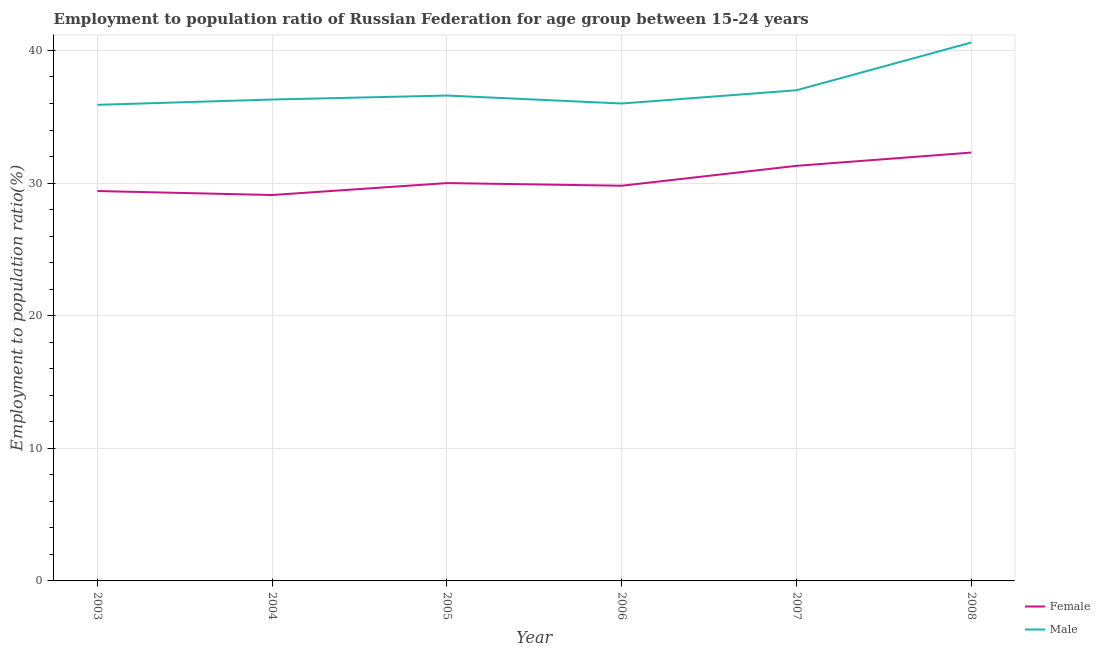Is the number of lines equal to the number of legend labels?
Keep it short and to the point. Yes. What is the employment to population ratio(female) in 2004?
Your response must be concise. 29.1. Across all years, what is the maximum employment to population ratio(male)?
Offer a terse response. 40.6. Across all years, what is the minimum employment to population ratio(female)?
Provide a succinct answer. 29.1. What is the total employment to population ratio(male) in the graph?
Ensure brevity in your answer.  222.4. What is the difference between the employment to population ratio(female) in 2005 and that in 2007?
Provide a short and direct response. -1.3. What is the difference between the employment to population ratio(male) in 2004 and the employment to population ratio(female) in 2007?
Provide a short and direct response. 5. What is the average employment to population ratio(female) per year?
Ensure brevity in your answer.  30.32. In the year 2007, what is the difference between the employment to population ratio(male) and employment to population ratio(female)?
Make the answer very short. 5.7. In how many years, is the employment to population ratio(female) greater than 2 %?
Your response must be concise. 6. What is the ratio of the employment to population ratio(male) in 2004 to that in 2007?
Provide a succinct answer. 0.98. Is the employment to population ratio(male) in 2004 less than that in 2007?
Provide a short and direct response. Yes. What is the difference between the highest and the second highest employment to population ratio(female)?
Provide a succinct answer. 1. What is the difference between the highest and the lowest employment to population ratio(female)?
Provide a succinct answer. 3.2. In how many years, is the employment to population ratio(female) greater than the average employment to population ratio(female) taken over all years?
Ensure brevity in your answer.  2. Does the employment to population ratio(male) monotonically increase over the years?
Provide a short and direct response. No. Is the employment to population ratio(male) strictly greater than the employment to population ratio(female) over the years?
Keep it short and to the point. Yes. Is the employment to population ratio(male) strictly less than the employment to population ratio(female) over the years?
Offer a very short reply. No. How many lines are there?
Provide a succinct answer. 2. How many years are there in the graph?
Offer a terse response. 6. What is the difference between two consecutive major ticks on the Y-axis?
Keep it short and to the point. 10. Are the values on the major ticks of Y-axis written in scientific E-notation?
Your answer should be very brief. No. How many legend labels are there?
Give a very brief answer. 2. What is the title of the graph?
Your answer should be compact. Employment to population ratio of Russian Federation for age group between 15-24 years. What is the label or title of the Y-axis?
Provide a succinct answer. Employment to population ratio(%). What is the Employment to population ratio(%) of Female in 2003?
Offer a terse response. 29.4. What is the Employment to population ratio(%) of Male in 2003?
Your response must be concise. 35.9. What is the Employment to population ratio(%) of Female in 2004?
Provide a succinct answer. 29.1. What is the Employment to population ratio(%) in Male in 2004?
Offer a very short reply. 36.3. What is the Employment to population ratio(%) of Female in 2005?
Ensure brevity in your answer.  30. What is the Employment to population ratio(%) in Male in 2005?
Your response must be concise. 36.6. What is the Employment to population ratio(%) of Female in 2006?
Keep it short and to the point. 29.8. What is the Employment to population ratio(%) in Male in 2006?
Make the answer very short. 36. What is the Employment to population ratio(%) of Female in 2007?
Make the answer very short. 31.3. What is the Employment to population ratio(%) of Male in 2007?
Ensure brevity in your answer.  37. What is the Employment to population ratio(%) of Female in 2008?
Provide a short and direct response. 32.3. What is the Employment to population ratio(%) of Male in 2008?
Your answer should be very brief. 40.6. Across all years, what is the maximum Employment to population ratio(%) in Female?
Provide a short and direct response. 32.3. Across all years, what is the maximum Employment to population ratio(%) of Male?
Keep it short and to the point. 40.6. Across all years, what is the minimum Employment to population ratio(%) of Female?
Offer a very short reply. 29.1. Across all years, what is the minimum Employment to population ratio(%) of Male?
Make the answer very short. 35.9. What is the total Employment to population ratio(%) in Female in the graph?
Give a very brief answer. 181.9. What is the total Employment to population ratio(%) of Male in the graph?
Keep it short and to the point. 222.4. What is the difference between the Employment to population ratio(%) of Male in 2003 and that in 2004?
Your answer should be compact. -0.4. What is the difference between the Employment to population ratio(%) in Female in 2003 and that in 2006?
Ensure brevity in your answer.  -0.4. What is the difference between the Employment to population ratio(%) in Male in 2003 and that in 2006?
Give a very brief answer. -0.1. What is the difference between the Employment to population ratio(%) in Female in 2003 and that in 2007?
Offer a very short reply. -1.9. What is the difference between the Employment to population ratio(%) in Male in 2004 and that in 2005?
Provide a succinct answer. -0.3. What is the difference between the Employment to population ratio(%) in Male in 2004 and that in 2006?
Provide a short and direct response. 0.3. What is the difference between the Employment to population ratio(%) of Female in 2004 and that in 2007?
Provide a succinct answer. -2.2. What is the difference between the Employment to population ratio(%) in Male in 2004 and that in 2008?
Ensure brevity in your answer.  -4.3. What is the difference between the Employment to population ratio(%) in Female in 2005 and that in 2006?
Your answer should be compact. 0.2. What is the difference between the Employment to population ratio(%) in Male in 2005 and that in 2008?
Ensure brevity in your answer.  -4. What is the difference between the Employment to population ratio(%) in Female in 2006 and that in 2008?
Your answer should be very brief. -2.5. What is the difference between the Employment to population ratio(%) in Male in 2007 and that in 2008?
Your answer should be compact. -3.6. What is the difference between the Employment to population ratio(%) of Female in 2003 and the Employment to population ratio(%) of Male in 2005?
Provide a short and direct response. -7.2. What is the difference between the Employment to population ratio(%) in Female in 2004 and the Employment to population ratio(%) in Male in 2005?
Offer a very short reply. -7.5. What is the difference between the Employment to population ratio(%) in Female in 2004 and the Employment to population ratio(%) in Male in 2007?
Your answer should be compact. -7.9. What is the difference between the Employment to population ratio(%) in Female in 2005 and the Employment to population ratio(%) in Male in 2006?
Ensure brevity in your answer.  -6. What is the average Employment to population ratio(%) in Female per year?
Keep it short and to the point. 30.32. What is the average Employment to population ratio(%) in Male per year?
Give a very brief answer. 37.07. In the year 2006, what is the difference between the Employment to population ratio(%) of Female and Employment to population ratio(%) of Male?
Your answer should be very brief. -6.2. What is the ratio of the Employment to population ratio(%) in Female in 2003 to that in 2004?
Keep it short and to the point. 1.01. What is the ratio of the Employment to population ratio(%) of Female in 2003 to that in 2005?
Provide a short and direct response. 0.98. What is the ratio of the Employment to population ratio(%) in Male in 2003 to that in 2005?
Your answer should be compact. 0.98. What is the ratio of the Employment to population ratio(%) in Female in 2003 to that in 2006?
Keep it short and to the point. 0.99. What is the ratio of the Employment to population ratio(%) of Female in 2003 to that in 2007?
Your answer should be very brief. 0.94. What is the ratio of the Employment to population ratio(%) in Male in 2003 to that in 2007?
Offer a terse response. 0.97. What is the ratio of the Employment to population ratio(%) in Female in 2003 to that in 2008?
Your response must be concise. 0.91. What is the ratio of the Employment to population ratio(%) of Male in 2003 to that in 2008?
Offer a terse response. 0.88. What is the ratio of the Employment to population ratio(%) in Female in 2004 to that in 2005?
Ensure brevity in your answer.  0.97. What is the ratio of the Employment to population ratio(%) of Female in 2004 to that in 2006?
Your answer should be very brief. 0.98. What is the ratio of the Employment to population ratio(%) in Male in 2004 to that in 2006?
Give a very brief answer. 1.01. What is the ratio of the Employment to population ratio(%) of Female in 2004 to that in 2007?
Keep it short and to the point. 0.93. What is the ratio of the Employment to population ratio(%) in Male in 2004 to that in 2007?
Provide a succinct answer. 0.98. What is the ratio of the Employment to population ratio(%) in Female in 2004 to that in 2008?
Offer a terse response. 0.9. What is the ratio of the Employment to population ratio(%) in Male in 2004 to that in 2008?
Give a very brief answer. 0.89. What is the ratio of the Employment to population ratio(%) in Female in 2005 to that in 2006?
Ensure brevity in your answer.  1.01. What is the ratio of the Employment to population ratio(%) of Male in 2005 to that in 2006?
Make the answer very short. 1.02. What is the ratio of the Employment to population ratio(%) in Female in 2005 to that in 2007?
Ensure brevity in your answer.  0.96. What is the ratio of the Employment to population ratio(%) of Female in 2005 to that in 2008?
Your answer should be very brief. 0.93. What is the ratio of the Employment to population ratio(%) in Male in 2005 to that in 2008?
Offer a very short reply. 0.9. What is the ratio of the Employment to population ratio(%) in Female in 2006 to that in 2007?
Keep it short and to the point. 0.95. What is the ratio of the Employment to population ratio(%) of Female in 2006 to that in 2008?
Ensure brevity in your answer.  0.92. What is the ratio of the Employment to population ratio(%) of Male in 2006 to that in 2008?
Your answer should be compact. 0.89. What is the ratio of the Employment to population ratio(%) of Male in 2007 to that in 2008?
Give a very brief answer. 0.91. What is the difference between the highest and the lowest Employment to population ratio(%) in Male?
Provide a succinct answer. 4.7. 